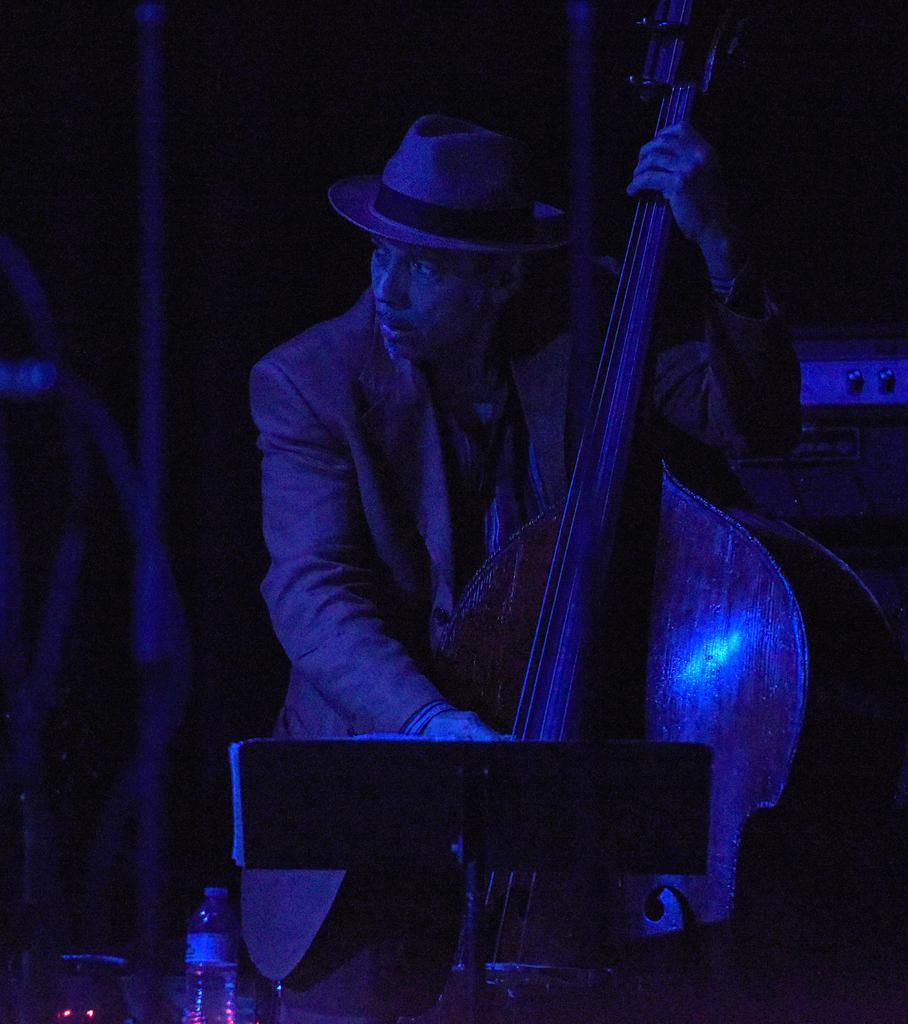How would you summarize this image in a sentence or two? In this image I can see a man is holding a musical instrument. I can also see he is wearing a cap and here I can see a bottle and a stand. 